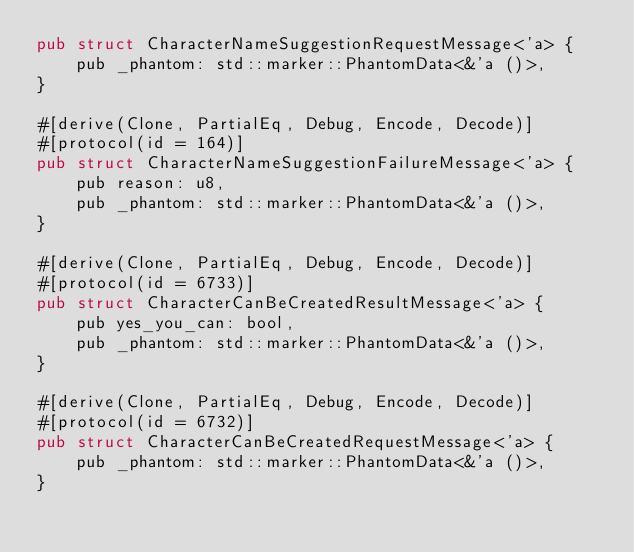Convert code to text. <code><loc_0><loc_0><loc_500><loc_500><_Rust_>pub struct CharacterNameSuggestionRequestMessage<'a> {
    pub _phantom: std::marker::PhantomData<&'a ()>,
}

#[derive(Clone, PartialEq, Debug, Encode, Decode)]
#[protocol(id = 164)]
pub struct CharacterNameSuggestionFailureMessage<'a> {
    pub reason: u8,
    pub _phantom: std::marker::PhantomData<&'a ()>,
}

#[derive(Clone, PartialEq, Debug, Encode, Decode)]
#[protocol(id = 6733)]
pub struct CharacterCanBeCreatedResultMessage<'a> {
    pub yes_you_can: bool,
    pub _phantom: std::marker::PhantomData<&'a ()>,
}

#[derive(Clone, PartialEq, Debug, Encode, Decode)]
#[protocol(id = 6732)]
pub struct CharacterCanBeCreatedRequestMessage<'a> {
    pub _phantom: std::marker::PhantomData<&'a ()>,
}
</code> 